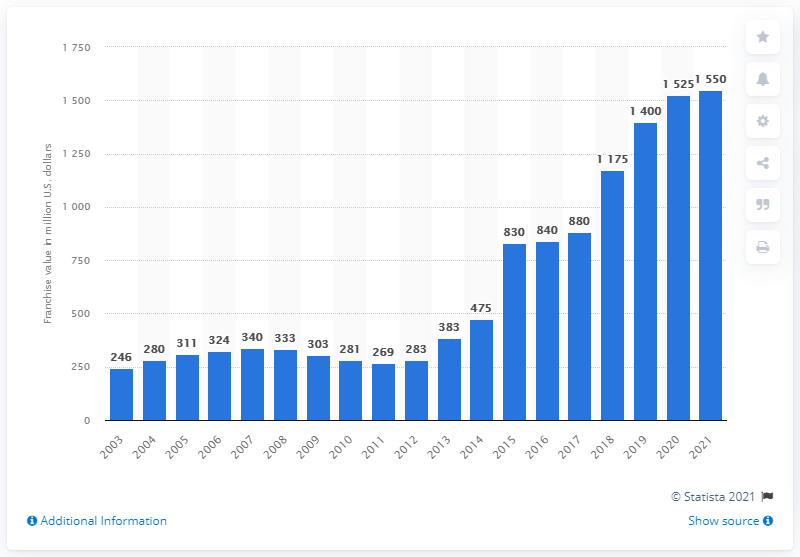Draw attention to some important aspects in this diagram. In 2021, the estimated value of the Indiana Pacers was approximately $1,550 million. 